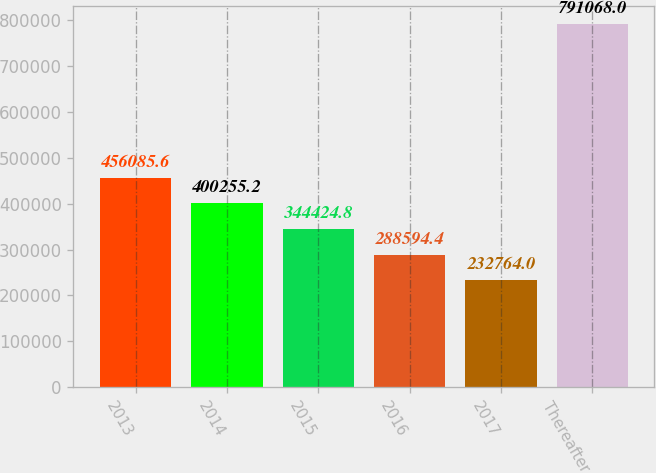<chart> <loc_0><loc_0><loc_500><loc_500><bar_chart><fcel>2013<fcel>2014<fcel>2015<fcel>2016<fcel>2017<fcel>Thereafter<nl><fcel>456086<fcel>400255<fcel>344425<fcel>288594<fcel>232764<fcel>791068<nl></chart> 